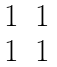<formula> <loc_0><loc_0><loc_500><loc_500>\begin{matrix} 1 & 1 \\ 1 & 1 \end{matrix}</formula> 